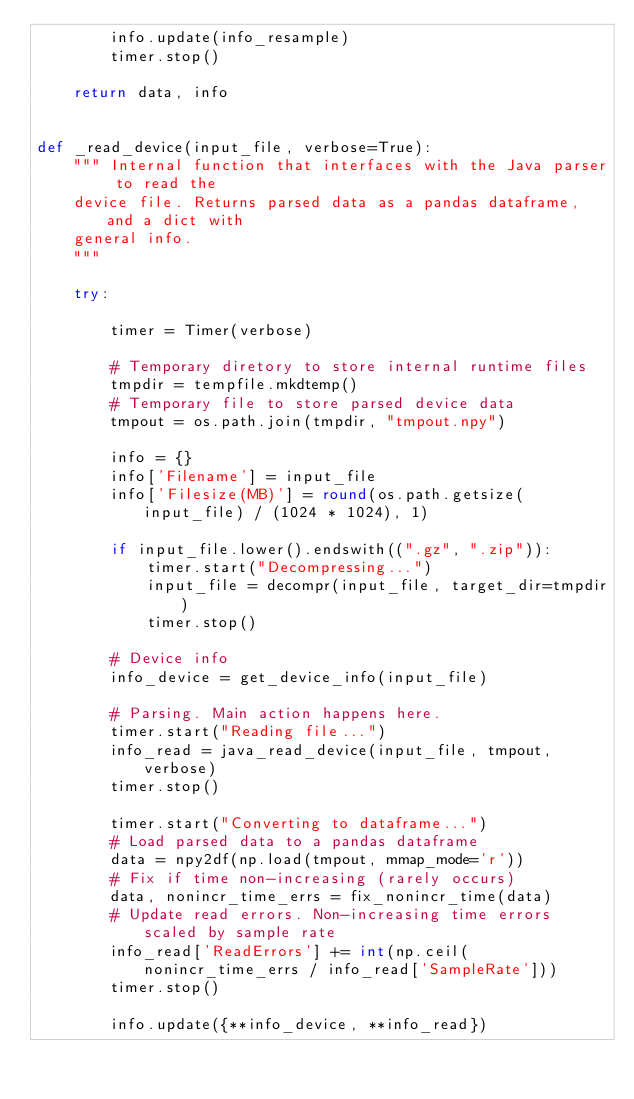<code> <loc_0><loc_0><loc_500><loc_500><_Python_>        info.update(info_resample)
        timer.stop()

    return data, info


def _read_device(input_file, verbose=True):
    """ Internal function that interfaces with the Java parser to read the
    device file. Returns parsed data as a pandas dataframe, and a dict with
    general info.
    """

    try:

        timer = Timer(verbose)

        # Temporary diretory to store internal runtime files
        tmpdir = tempfile.mkdtemp()
        # Temporary file to store parsed device data
        tmpout = os.path.join(tmpdir, "tmpout.npy")

        info = {}
        info['Filename'] = input_file
        info['Filesize(MB)'] = round(os.path.getsize(input_file) / (1024 * 1024), 1)

        if input_file.lower().endswith((".gz", ".zip")):
            timer.start("Decompressing...")
            input_file = decompr(input_file, target_dir=tmpdir)
            timer.stop()

        # Device info
        info_device = get_device_info(input_file)

        # Parsing. Main action happens here.
        timer.start("Reading file...")
        info_read = java_read_device(input_file, tmpout, verbose)
        timer.stop()

        timer.start("Converting to dataframe...")
        # Load parsed data to a pandas dataframe
        data = npy2df(np.load(tmpout, mmap_mode='r'))
        # Fix if time non-increasing (rarely occurs)
        data, nonincr_time_errs = fix_nonincr_time(data)
        # Update read errors. Non-increasing time errors scaled by sample rate
        info_read['ReadErrors'] += int(np.ceil(nonincr_time_errs / info_read['SampleRate']))
        timer.stop()

        info.update({**info_device, **info_read})
</code> 